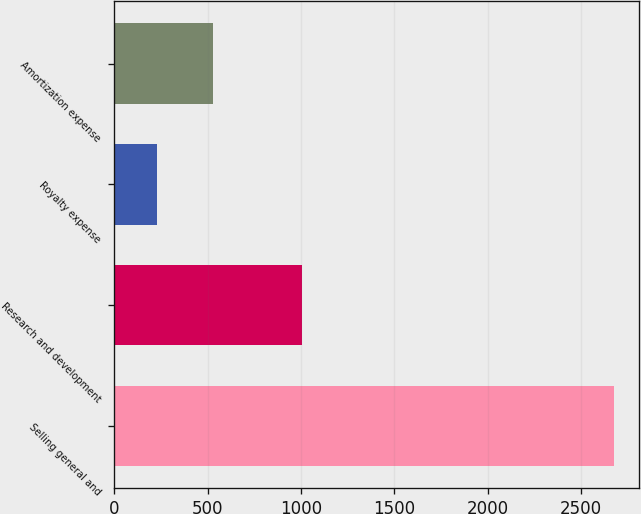<chart> <loc_0><loc_0><loc_500><loc_500><bar_chart><fcel>Selling general and<fcel>Research and development<fcel>Royalty expense<fcel>Amortization expense<nl><fcel>2675<fcel>1008<fcel>231<fcel>530<nl></chart> 